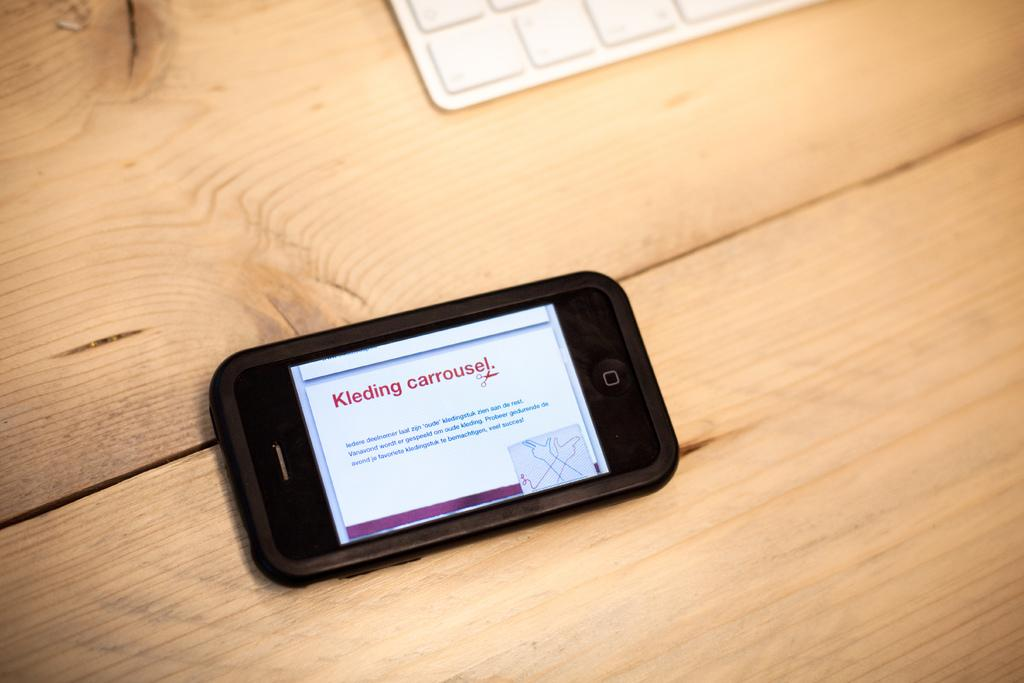<image>
Describe the image concisely. Black cell phone that says "kleding carrousel" on it. 